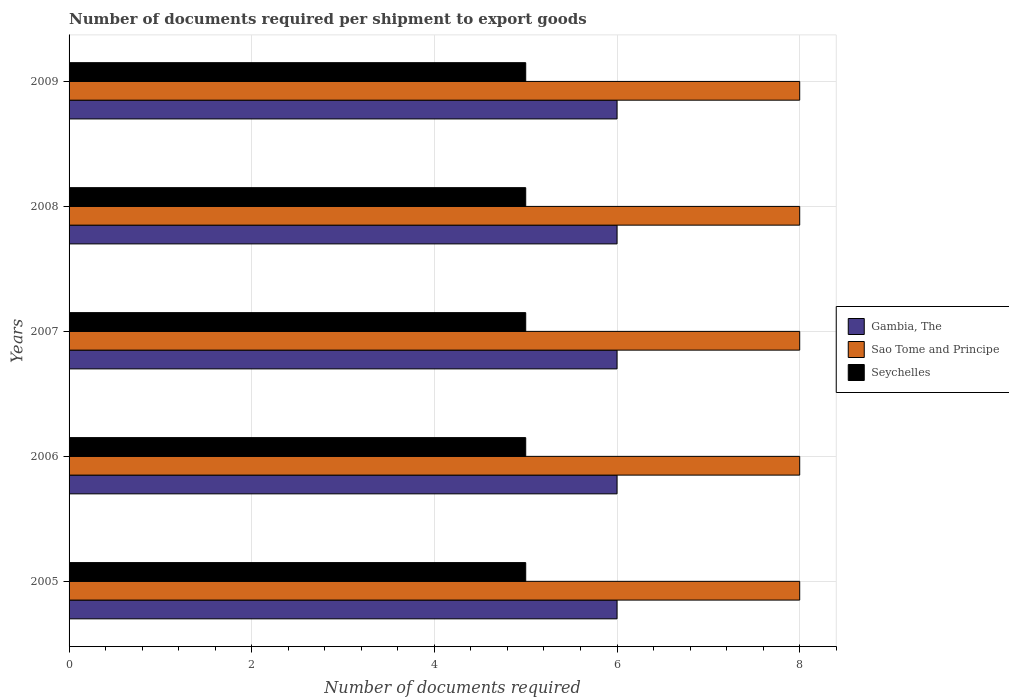How many different coloured bars are there?
Keep it short and to the point. 3. How many groups of bars are there?
Your answer should be compact. 5. Are the number of bars on each tick of the Y-axis equal?
Your answer should be very brief. Yes. How many bars are there on the 5th tick from the bottom?
Your answer should be compact. 3. What is the label of the 4th group of bars from the top?
Provide a short and direct response. 2006. What is the number of documents required per shipment to export goods in Seychelles in 2006?
Your response must be concise. 5. Across all years, what is the maximum number of documents required per shipment to export goods in Seychelles?
Provide a short and direct response. 5. Across all years, what is the minimum number of documents required per shipment to export goods in Seychelles?
Your response must be concise. 5. In which year was the number of documents required per shipment to export goods in Gambia, The minimum?
Give a very brief answer. 2005. What is the total number of documents required per shipment to export goods in Seychelles in the graph?
Keep it short and to the point. 25. What is the difference between the number of documents required per shipment to export goods in Gambia, The in 2009 and the number of documents required per shipment to export goods in Sao Tome and Principe in 2007?
Your response must be concise. -2. In the year 2009, what is the difference between the number of documents required per shipment to export goods in Seychelles and number of documents required per shipment to export goods in Sao Tome and Principe?
Give a very brief answer. -3. In how many years, is the number of documents required per shipment to export goods in Gambia, The greater than 4.4 ?
Ensure brevity in your answer.  5. Is the difference between the number of documents required per shipment to export goods in Seychelles in 2005 and 2007 greater than the difference between the number of documents required per shipment to export goods in Sao Tome and Principe in 2005 and 2007?
Your answer should be compact. No. What is the difference between the highest and the second highest number of documents required per shipment to export goods in Seychelles?
Ensure brevity in your answer.  0. Is the sum of the number of documents required per shipment to export goods in Seychelles in 2008 and 2009 greater than the maximum number of documents required per shipment to export goods in Sao Tome and Principe across all years?
Offer a very short reply. Yes. What does the 1st bar from the top in 2005 represents?
Your response must be concise. Seychelles. What does the 2nd bar from the bottom in 2008 represents?
Keep it short and to the point. Sao Tome and Principe. Is it the case that in every year, the sum of the number of documents required per shipment to export goods in Seychelles and number of documents required per shipment to export goods in Gambia, The is greater than the number of documents required per shipment to export goods in Sao Tome and Principe?
Your answer should be very brief. Yes. How many bars are there?
Ensure brevity in your answer.  15. Are all the bars in the graph horizontal?
Your response must be concise. Yes. How many years are there in the graph?
Keep it short and to the point. 5. What is the difference between two consecutive major ticks on the X-axis?
Ensure brevity in your answer.  2. Are the values on the major ticks of X-axis written in scientific E-notation?
Provide a succinct answer. No. Does the graph contain grids?
Give a very brief answer. Yes. What is the title of the graph?
Keep it short and to the point. Number of documents required per shipment to export goods. What is the label or title of the X-axis?
Offer a terse response. Number of documents required. What is the label or title of the Y-axis?
Offer a terse response. Years. What is the Number of documents required in Seychelles in 2005?
Provide a short and direct response. 5. What is the Number of documents required in Gambia, The in 2006?
Provide a short and direct response. 6. What is the Number of documents required in Sao Tome and Principe in 2006?
Make the answer very short. 8. What is the Number of documents required in Gambia, The in 2007?
Your response must be concise. 6. What is the Number of documents required of Sao Tome and Principe in 2007?
Offer a terse response. 8. What is the Number of documents required in Seychelles in 2007?
Provide a short and direct response. 5. What is the Number of documents required of Gambia, The in 2008?
Provide a succinct answer. 6. What is the Number of documents required in Seychelles in 2008?
Your answer should be very brief. 5. What is the Number of documents required of Gambia, The in 2009?
Ensure brevity in your answer.  6. Across all years, what is the maximum Number of documents required in Sao Tome and Principe?
Ensure brevity in your answer.  8. Across all years, what is the maximum Number of documents required in Seychelles?
Give a very brief answer. 5. Across all years, what is the minimum Number of documents required in Gambia, The?
Provide a short and direct response. 6. What is the total Number of documents required of Gambia, The in the graph?
Give a very brief answer. 30. What is the total Number of documents required of Sao Tome and Principe in the graph?
Ensure brevity in your answer.  40. What is the difference between the Number of documents required of Sao Tome and Principe in 2005 and that in 2007?
Give a very brief answer. 0. What is the difference between the Number of documents required in Seychelles in 2005 and that in 2007?
Your response must be concise. 0. What is the difference between the Number of documents required of Gambia, The in 2005 and that in 2008?
Your answer should be very brief. 0. What is the difference between the Number of documents required of Seychelles in 2005 and that in 2008?
Your answer should be compact. 0. What is the difference between the Number of documents required in Sao Tome and Principe in 2005 and that in 2009?
Ensure brevity in your answer.  0. What is the difference between the Number of documents required in Seychelles in 2005 and that in 2009?
Give a very brief answer. 0. What is the difference between the Number of documents required of Gambia, The in 2006 and that in 2008?
Offer a terse response. 0. What is the difference between the Number of documents required of Gambia, The in 2006 and that in 2009?
Offer a very short reply. 0. What is the difference between the Number of documents required of Sao Tome and Principe in 2006 and that in 2009?
Ensure brevity in your answer.  0. What is the difference between the Number of documents required of Gambia, The in 2007 and that in 2009?
Offer a terse response. 0. What is the difference between the Number of documents required in Seychelles in 2007 and that in 2009?
Make the answer very short. 0. What is the difference between the Number of documents required of Seychelles in 2008 and that in 2009?
Your answer should be compact. 0. What is the difference between the Number of documents required of Gambia, The in 2005 and the Number of documents required of Sao Tome and Principe in 2006?
Give a very brief answer. -2. What is the difference between the Number of documents required in Gambia, The in 2005 and the Number of documents required in Sao Tome and Principe in 2007?
Your response must be concise. -2. What is the difference between the Number of documents required in Sao Tome and Principe in 2005 and the Number of documents required in Seychelles in 2007?
Keep it short and to the point. 3. What is the difference between the Number of documents required in Gambia, The in 2005 and the Number of documents required in Seychelles in 2008?
Your answer should be compact. 1. What is the difference between the Number of documents required in Sao Tome and Principe in 2005 and the Number of documents required in Seychelles in 2008?
Give a very brief answer. 3. What is the difference between the Number of documents required in Gambia, The in 2005 and the Number of documents required in Sao Tome and Principe in 2009?
Offer a very short reply. -2. What is the difference between the Number of documents required of Gambia, The in 2005 and the Number of documents required of Seychelles in 2009?
Provide a succinct answer. 1. What is the difference between the Number of documents required in Sao Tome and Principe in 2005 and the Number of documents required in Seychelles in 2009?
Make the answer very short. 3. What is the difference between the Number of documents required of Gambia, The in 2006 and the Number of documents required of Sao Tome and Principe in 2007?
Offer a very short reply. -2. What is the difference between the Number of documents required in Sao Tome and Principe in 2006 and the Number of documents required in Seychelles in 2007?
Make the answer very short. 3. What is the difference between the Number of documents required in Gambia, The in 2006 and the Number of documents required in Sao Tome and Principe in 2009?
Offer a terse response. -2. What is the difference between the Number of documents required of Gambia, The in 2007 and the Number of documents required of Sao Tome and Principe in 2008?
Give a very brief answer. -2. What is the difference between the Number of documents required in Sao Tome and Principe in 2007 and the Number of documents required in Seychelles in 2008?
Your answer should be very brief. 3. What is the difference between the Number of documents required in Sao Tome and Principe in 2007 and the Number of documents required in Seychelles in 2009?
Your answer should be compact. 3. What is the difference between the Number of documents required of Gambia, The in 2008 and the Number of documents required of Seychelles in 2009?
Give a very brief answer. 1. What is the difference between the Number of documents required in Sao Tome and Principe in 2008 and the Number of documents required in Seychelles in 2009?
Offer a very short reply. 3. What is the average Number of documents required in Gambia, The per year?
Provide a succinct answer. 6. What is the average Number of documents required in Seychelles per year?
Ensure brevity in your answer.  5. In the year 2005, what is the difference between the Number of documents required of Gambia, The and Number of documents required of Sao Tome and Principe?
Your answer should be very brief. -2. In the year 2005, what is the difference between the Number of documents required in Sao Tome and Principe and Number of documents required in Seychelles?
Make the answer very short. 3. In the year 2006, what is the difference between the Number of documents required of Gambia, The and Number of documents required of Sao Tome and Principe?
Ensure brevity in your answer.  -2. In the year 2007, what is the difference between the Number of documents required in Gambia, The and Number of documents required in Sao Tome and Principe?
Offer a very short reply. -2. In the year 2008, what is the difference between the Number of documents required of Gambia, The and Number of documents required of Sao Tome and Principe?
Keep it short and to the point. -2. In the year 2009, what is the difference between the Number of documents required of Gambia, The and Number of documents required of Seychelles?
Provide a succinct answer. 1. What is the ratio of the Number of documents required of Gambia, The in 2005 to that in 2006?
Offer a terse response. 1. What is the ratio of the Number of documents required of Sao Tome and Principe in 2005 to that in 2006?
Give a very brief answer. 1. What is the ratio of the Number of documents required in Gambia, The in 2005 to that in 2007?
Your answer should be compact. 1. What is the ratio of the Number of documents required of Seychelles in 2005 to that in 2007?
Provide a short and direct response. 1. What is the ratio of the Number of documents required in Sao Tome and Principe in 2005 to that in 2008?
Provide a succinct answer. 1. What is the ratio of the Number of documents required of Seychelles in 2005 to that in 2008?
Ensure brevity in your answer.  1. What is the ratio of the Number of documents required in Gambia, The in 2005 to that in 2009?
Your answer should be compact. 1. What is the ratio of the Number of documents required of Gambia, The in 2006 to that in 2007?
Your answer should be compact. 1. What is the ratio of the Number of documents required in Sao Tome and Principe in 2006 to that in 2007?
Offer a terse response. 1. What is the ratio of the Number of documents required of Gambia, The in 2006 to that in 2009?
Provide a short and direct response. 1. What is the ratio of the Number of documents required in Gambia, The in 2007 to that in 2008?
Offer a very short reply. 1. What is the ratio of the Number of documents required in Seychelles in 2007 to that in 2009?
Your answer should be compact. 1. What is the difference between the highest and the second highest Number of documents required in Seychelles?
Ensure brevity in your answer.  0. What is the difference between the highest and the lowest Number of documents required of Gambia, The?
Keep it short and to the point. 0. What is the difference between the highest and the lowest Number of documents required of Sao Tome and Principe?
Give a very brief answer. 0. What is the difference between the highest and the lowest Number of documents required of Seychelles?
Provide a succinct answer. 0. 